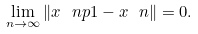<formula> <loc_0><loc_0><loc_500><loc_500>\lim _ { n \to \infty } \| x \ n p 1 - x \ n \| = 0 .</formula> 